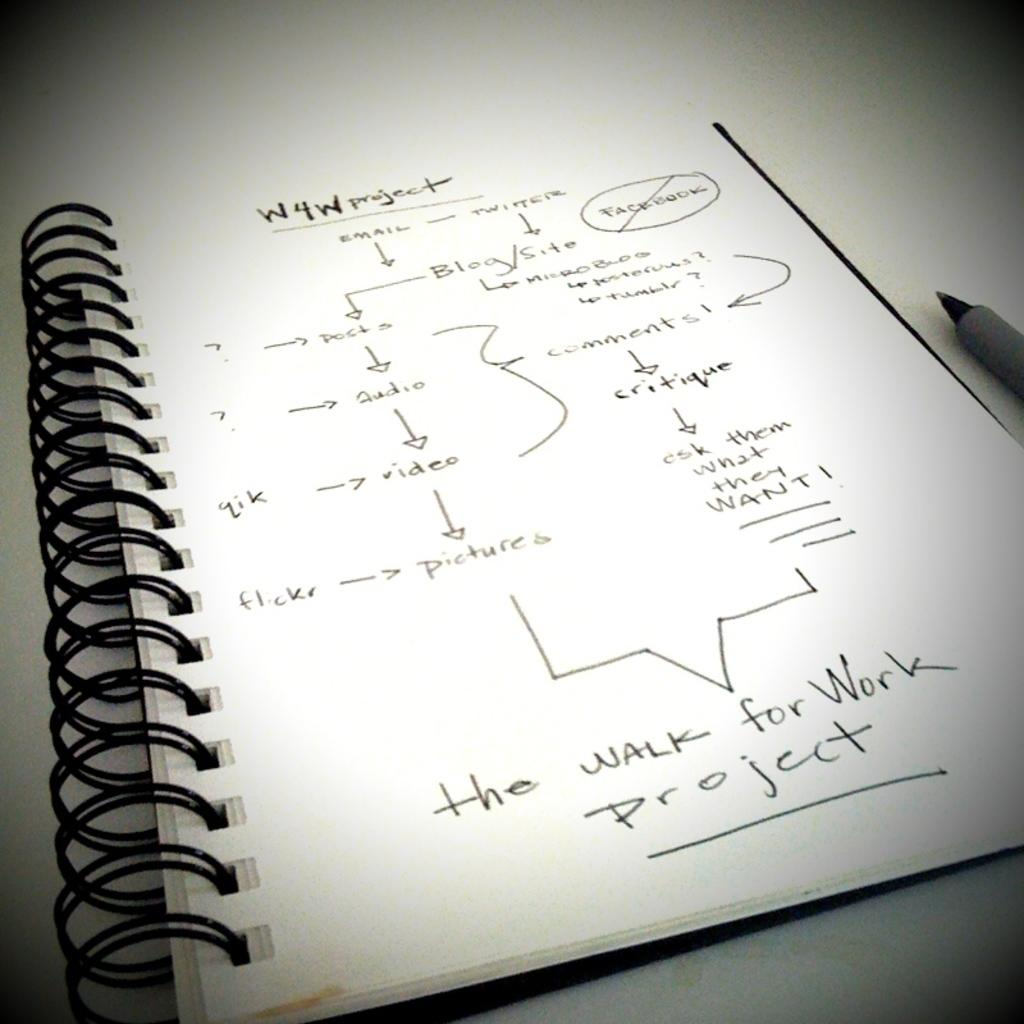<image>
Give a short and clear explanation of the subsequent image. A wire bound notebook with lists that says the Walk for Work project at the bottom. 